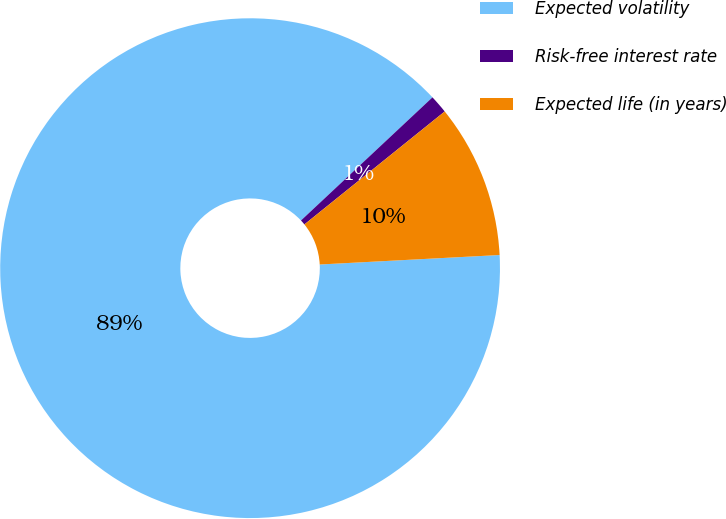<chart> <loc_0><loc_0><loc_500><loc_500><pie_chart><fcel>Expected volatility<fcel>Risk-free interest rate<fcel>Expected life (in years)<nl><fcel>88.86%<fcel>1.19%<fcel>9.95%<nl></chart> 